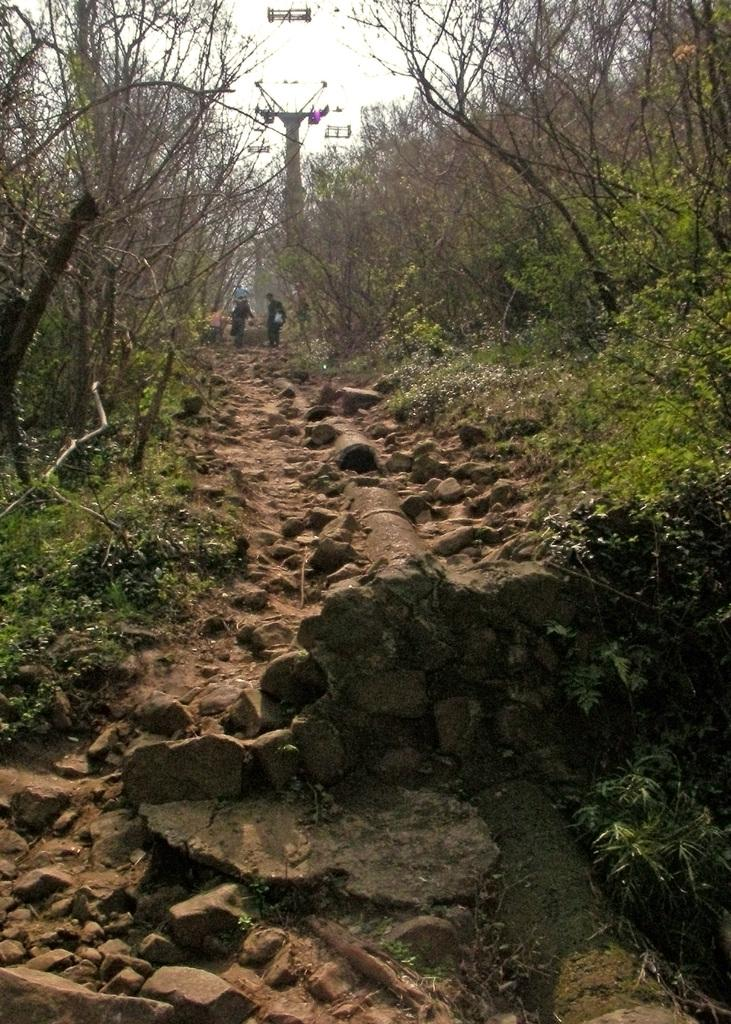How many people are in the image? There are two people in the image. What are the people doing in the image? The people are standing on a rocky walking path. What type of vegetation can be seen on either side of the path? Trees and bushes are present on either side of the path. Is the grandmother driving the car in the image? There is no car or grandmother present in the image. How long have the people been sleeping in the image? The people are not sleeping in the image; they are standing on a rocky walking path. 